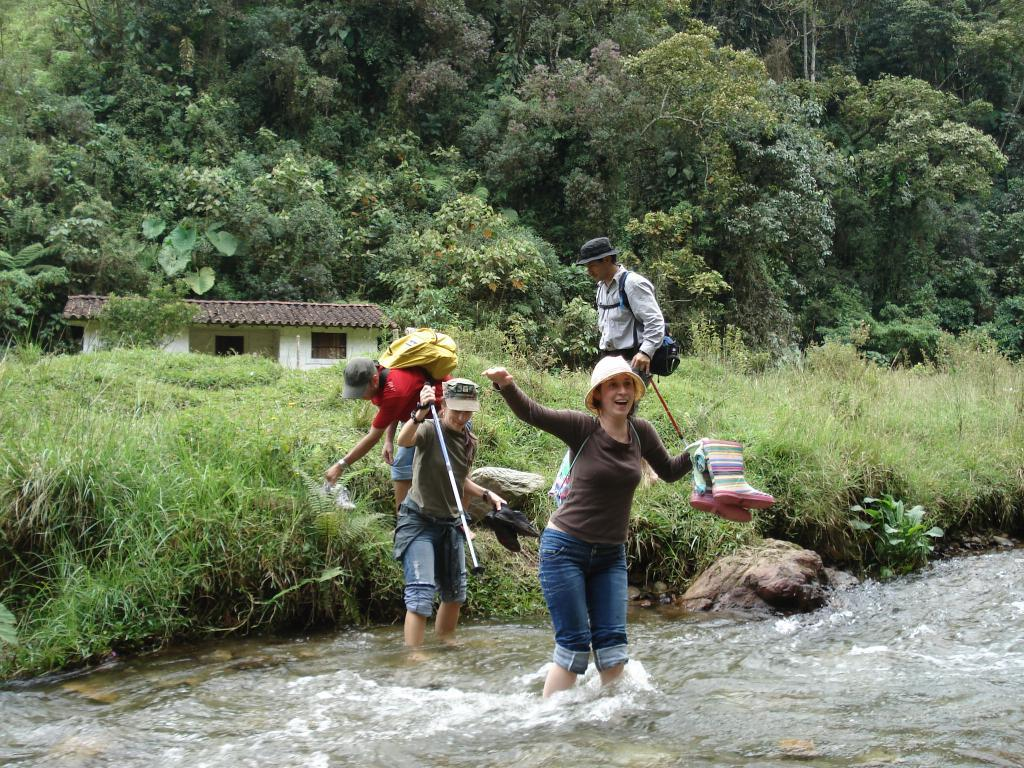How many people are in the image? There are four members in the image. What are two of the members doing in the image? Two of the members are walking in the water. What type of terrain is visible in the image? There is grass on the ground. What type of structure is present in the image? There is a house in the image. What can be seen in the background of the image? There are trees in the background of the image. What type of cause is being discussed by the members in the image? There is no indication in the image that the members are discussing any cause. Can you see a rabbit in the image? There is no rabbit present in the image. 